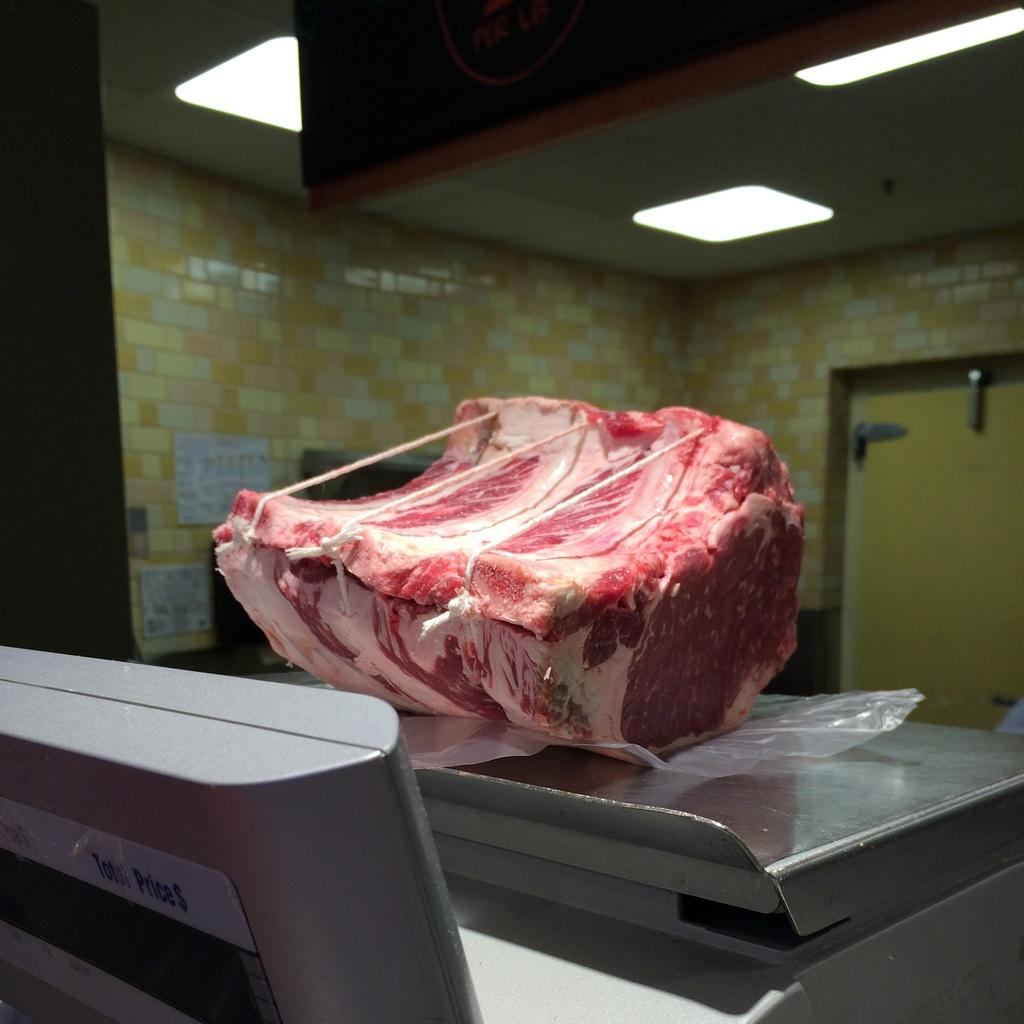What is the main subject in the center of the image? There is a piece of meat in the center of the image. What is the piece of meat placed on? The meat is on a weighing machine. What can be seen in the background of the image? There is a door and a wall in the background of the image. What type of elbow disease is visible on the piece of meat in the image? There is no elbow disease present on the piece of meat in the image, as it is a physical object and not a living organism. 